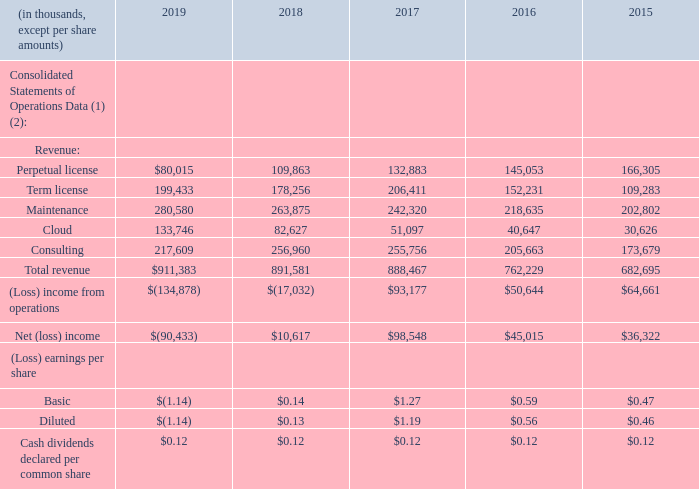ITEM 6. SELECTED FINANCIAL DATA
The selected financial data presented below has been derived from our audited consolidated financial statements. This data should be read in conjunction with “Item 7. Management’s Discussion and Analysis of Financial Condition and Results of Operations” and “Item 8. Financial Statements and Supplementary Data” of this Annual Report.
(1) We elected to early adopt Accounting Standards Update (“ASU”) 2016-09 “Compensation - Stock Compensation (Topic 718): Improvements to Employee Share-Based Payment Accounting” (“ASU 2016-09”) in 2016, which requires us, among other things, to prospectively record excess tax benefits as a reduction of the provision for income taxes in the consolidated statement of operations, whereas they were previously recognized in equity.
(2) We retrospectively adopted ASU 2014-09, “Revenue from Contracts with Customers (Topic 606)” in 2018. As a result, we have adjusted balances for 2017 and 2016. We have not adjusted 2015 for ASU 2014-09.
What are the respective revenue from perpetual license in 2015 and 2016?
Answer scale should be: thousand. 166,305, 145,053. What are the respective revenue from perpetual license in 2016 and 2017?
Answer scale should be: thousand. 145,053, 132,883. What are the respective revenue from perpetual license in 2018 and 2019?
Answer scale should be: thousand. 109,863, 80,015. What is the percentage change in the revenue earned from term license between 2015 and 2016?
Answer scale should be: percent. (152,231 - 109,283)/109,283 
Answer: 39.3. What is the percentage change in the revenue earned from perpetual license between 2018 and 2019?
Answer scale should be: percent. (80,015 - 109,863)/109,863 
Answer: -27.17. What is the total revenue earned from maintenance in 2017 and 2018?
Answer scale should be: thousand. 242,320 + 263,875 
Answer: 506195. 